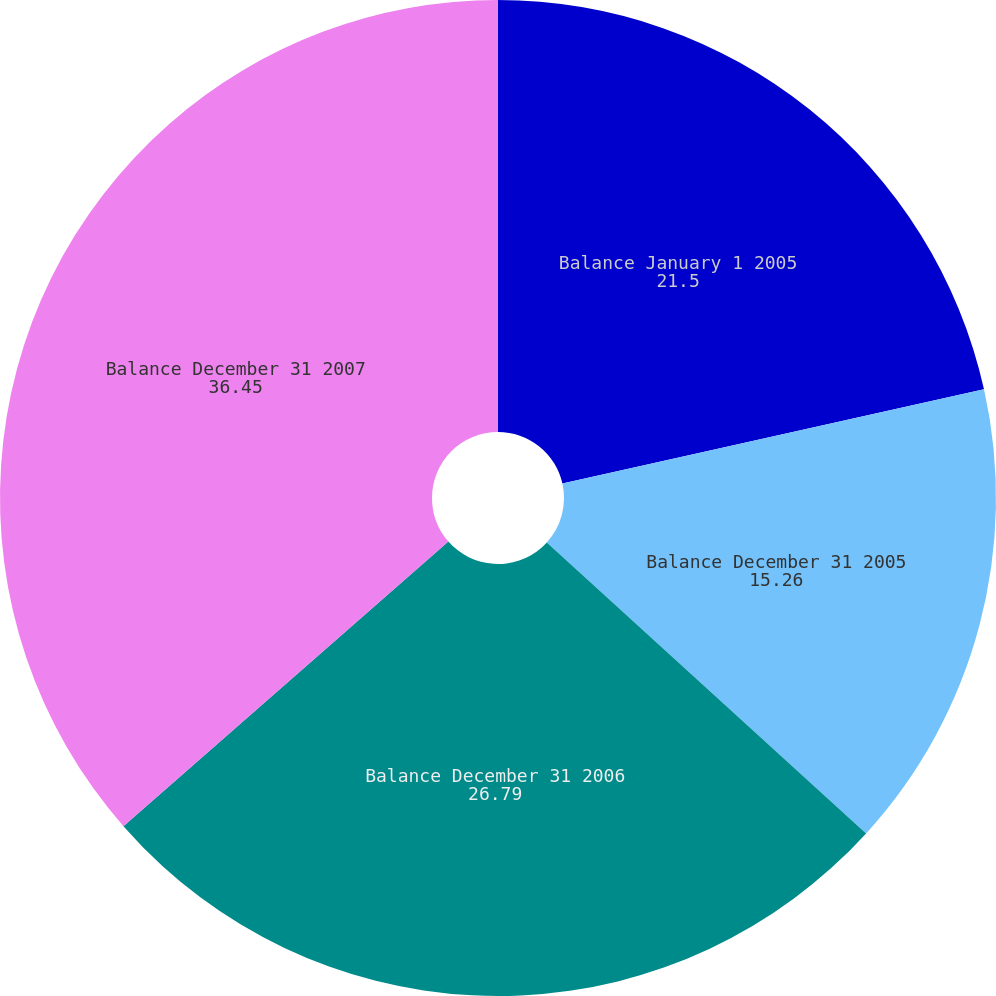Convert chart to OTSL. <chart><loc_0><loc_0><loc_500><loc_500><pie_chart><fcel>Balance January 1 2005<fcel>Balance December 31 2005<fcel>Balance December 31 2006<fcel>Balance December 31 2007<nl><fcel>21.5%<fcel>15.26%<fcel>26.79%<fcel>36.45%<nl></chart> 